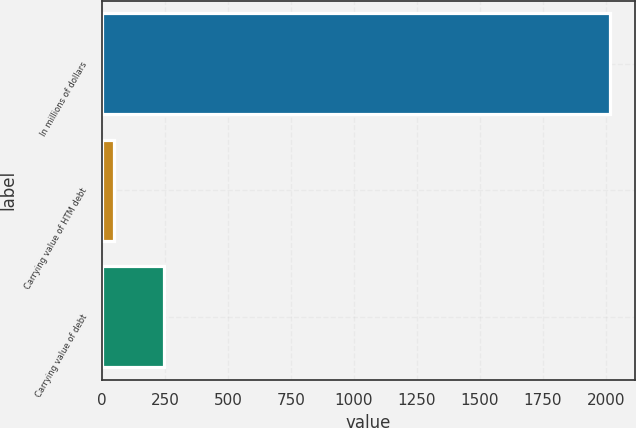Convert chart. <chart><loc_0><loc_0><loc_500><loc_500><bar_chart><fcel>In millions of dollars<fcel>Carrying value of HTM debt<fcel>Carrying value of debt<nl><fcel>2016<fcel>49<fcel>245.7<nl></chart> 